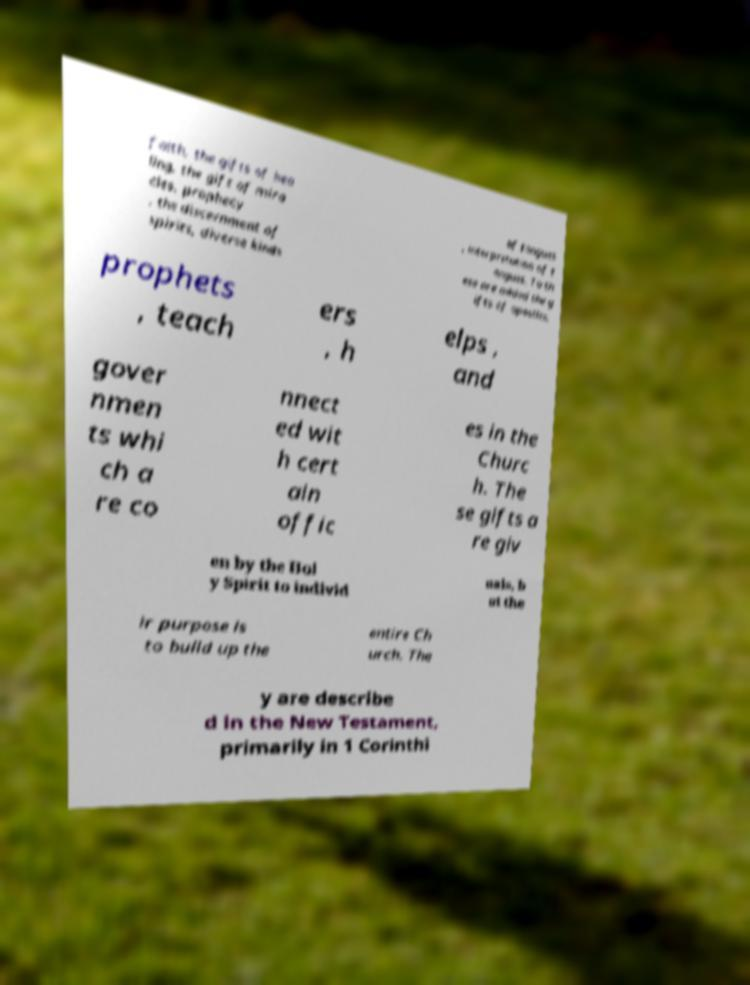Please read and relay the text visible in this image. What does it say? faith, the gifts of hea ling, the gift of mira cles, prophecy , the discernment of spirits, diverse kinds of tongues , interpretation of t ongues. To th ese are added the g ifts of apostles, prophets , teach ers , h elps , and gover nmen ts whi ch a re co nnect ed wit h cert ain offic es in the Churc h. The se gifts a re giv en by the Hol y Spirit to individ uals, b ut the ir purpose is to build up the entire Ch urch. The y are describe d in the New Testament, primarily in 1 Corinthi 